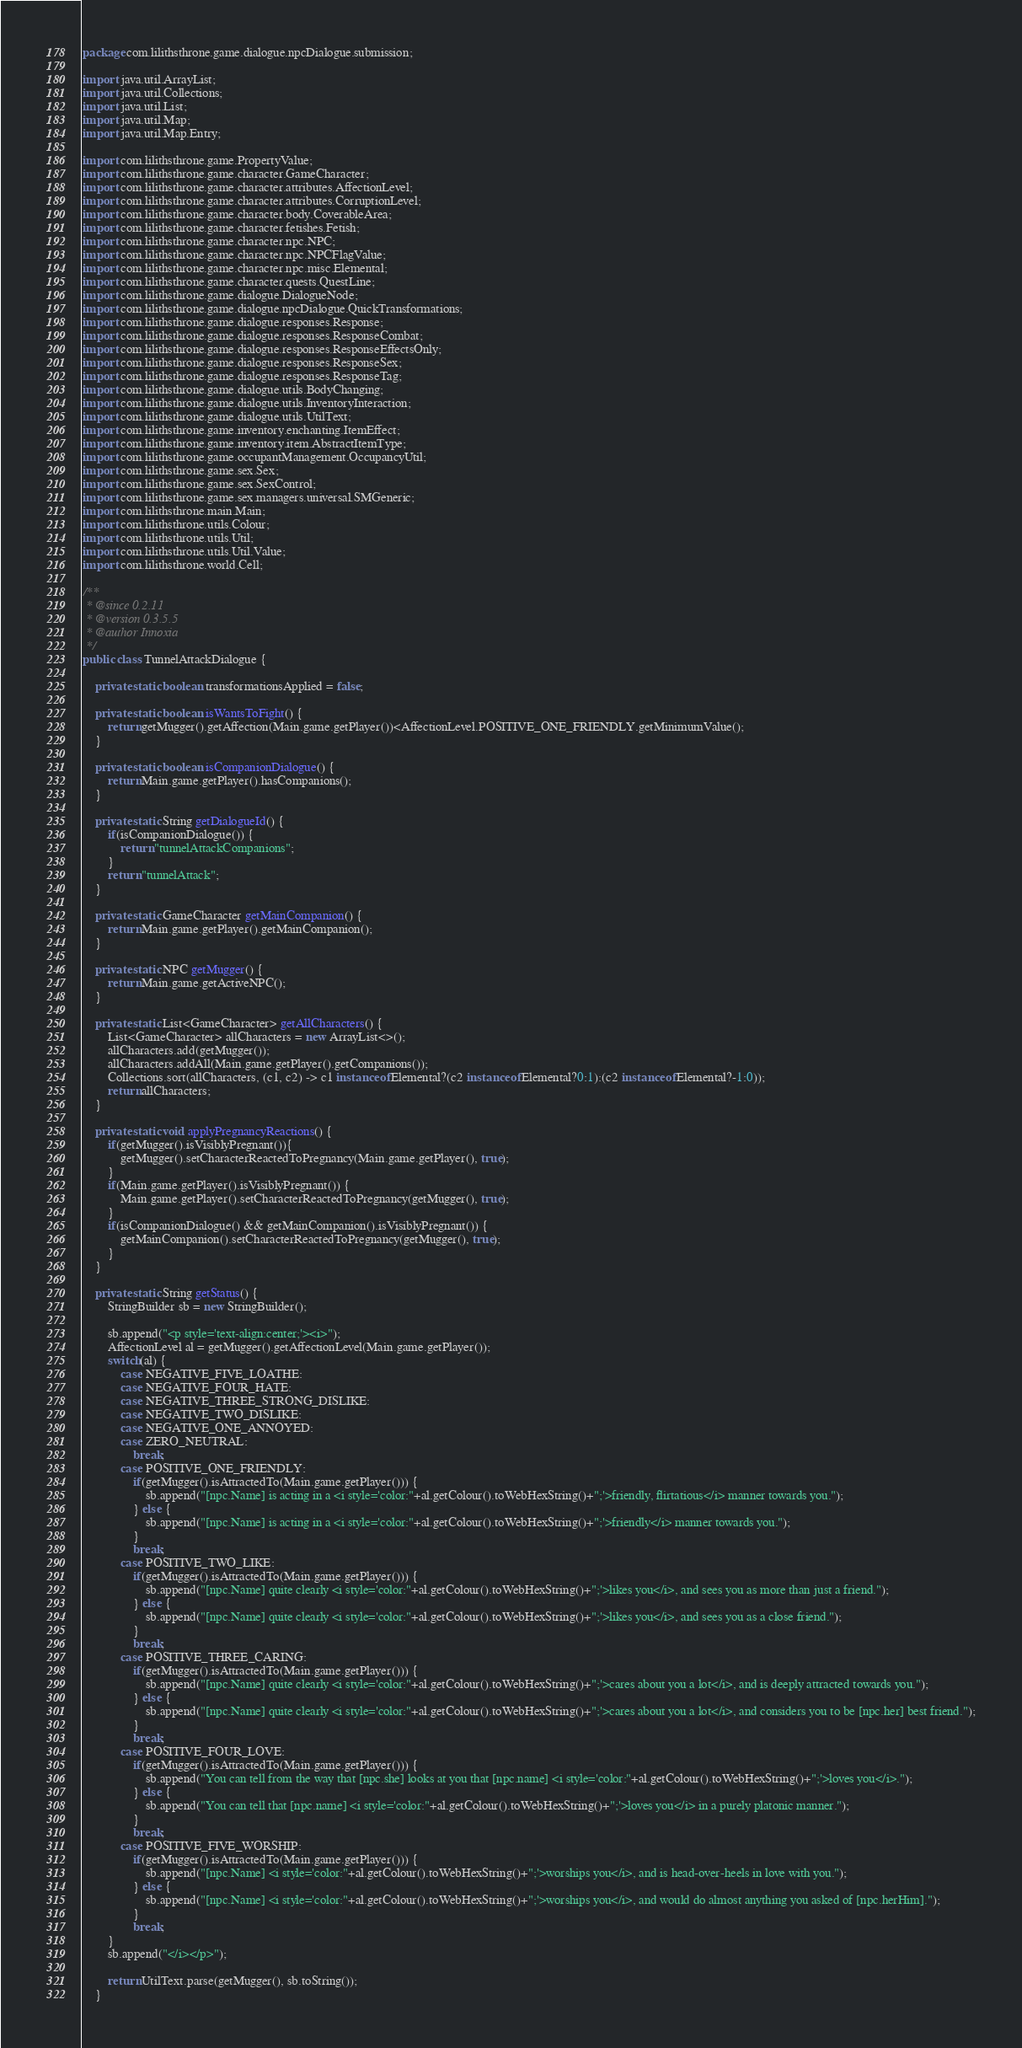Convert code to text. <code><loc_0><loc_0><loc_500><loc_500><_Java_>package com.lilithsthrone.game.dialogue.npcDialogue.submission;

import java.util.ArrayList;
import java.util.Collections;
import java.util.List;
import java.util.Map;
import java.util.Map.Entry;

import com.lilithsthrone.game.PropertyValue;
import com.lilithsthrone.game.character.GameCharacter;
import com.lilithsthrone.game.character.attributes.AffectionLevel;
import com.lilithsthrone.game.character.attributes.CorruptionLevel;
import com.lilithsthrone.game.character.body.CoverableArea;
import com.lilithsthrone.game.character.fetishes.Fetish;
import com.lilithsthrone.game.character.npc.NPC;
import com.lilithsthrone.game.character.npc.NPCFlagValue;
import com.lilithsthrone.game.character.npc.misc.Elemental;
import com.lilithsthrone.game.character.quests.QuestLine;
import com.lilithsthrone.game.dialogue.DialogueNode;
import com.lilithsthrone.game.dialogue.npcDialogue.QuickTransformations;
import com.lilithsthrone.game.dialogue.responses.Response;
import com.lilithsthrone.game.dialogue.responses.ResponseCombat;
import com.lilithsthrone.game.dialogue.responses.ResponseEffectsOnly;
import com.lilithsthrone.game.dialogue.responses.ResponseSex;
import com.lilithsthrone.game.dialogue.responses.ResponseTag;
import com.lilithsthrone.game.dialogue.utils.BodyChanging;
import com.lilithsthrone.game.dialogue.utils.InventoryInteraction;
import com.lilithsthrone.game.dialogue.utils.UtilText;
import com.lilithsthrone.game.inventory.enchanting.ItemEffect;
import com.lilithsthrone.game.inventory.item.AbstractItemType;
import com.lilithsthrone.game.occupantManagement.OccupancyUtil;
import com.lilithsthrone.game.sex.Sex;
import com.lilithsthrone.game.sex.SexControl;
import com.lilithsthrone.game.sex.managers.universal.SMGeneric;
import com.lilithsthrone.main.Main;
import com.lilithsthrone.utils.Colour;
import com.lilithsthrone.utils.Util;
import com.lilithsthrone.utils.Util.Value;
import com.lilithsthrone.world.Cell;

/**
 * @since 0.2.11
 * @version 0.3.5.5
 * @author Innoxia
 */
public class TunnelAttackDialogue {

	private static boolean transformationsApplied = false;
	
	private static boolean isWantsToFight() {
		return getMugger().getAffection(Main.game.getPlayer())<AffectionLevel.POSITIVE_ONE_FRIENDLY.getMinimumValue();
	}

	private static boolean isCompanionDialogue() {
		return Main.game.getPlayer().hasCompanions();
	}
	
	private static String getDialogueId() {
		if(isCompanionDialogue()) {
			return "tunnelAttackCompanions";
		}
		return "tunnelAttack";
	}

	private static GameCharacter getMainCompanion() {
		return Main.game.getPlayer().getMainCompanion();
	}
	
	private static NPC getMugger() {
		return Main.game.getActiveNPC();
	}
	
	private static List<GameCharacter> getAllCharacters() {
		List<GameCharacter> allCharacters = new ArrayList<>();
		allCharacters.add(getMugger());
		allCharacters.addAll(Main.game.getPlayer().getCompanions());
		Collections.sort(allCharacters, (c1, c2) -> c1 instanceof Elemental?(c2 instanceof Elemental?0:1):(c2 instanceof Elemental?-1:0));
		return allCharacters;
	}
	
	private static void applyPregnancyReactions() {
		if(getMugger().isVisiblyPregnant()){
			getMugger().setCharacterReactedToPregnancy(Main.game.getPlayer(), true);
		}
		if(Main.game.getPlayer().isVisiblyPregnant()) {
			Main.game.getPlayer().setCharacterReactedToPregnancy(getMugger(), true);
		}
		if(isCompanionDialogue() && getMainCompanion().isVisiblyPregnant()) {
			getMainCompanion().setCharacterReactedToPregnancy(getMugger(), true);
		}
	}
	
	private static String getStatus() {
		StringBuilder sb = new StringBuilder();
		
		sb.append("<p style='text-align:center;'><i>");
		AffectionLevel al = getMugger().getAffectionLevel(Main.game.getPlayer());
		switch(al) {
			case NEGATIVE_FIVE_LOATHE:
			case NEGATIVE_FOUR_HATE:
			case NEGATIVE_THREE_STRONG_DISLIKE:
			case NEGATIVE_TWO_DISLIKE:
			case NEGATIVE_ONE_ANNOYED:
			case ZERO_NEUTRAL:
				break;
			case POSITIVE_ONE_FRIENDLY:
				if(getMugger().isAttractedTo(Main.game.getPlayer())) {
					sb.append("[npc.Name] is acting in a <i style='color:"+al.getColour().toWebHexString()+";'>friendly, flirtatious</i> manner towards you.");
				} else {
					sb.append("[npc.Name] is acting in a <i style='color:"+al.getColour().toWebHexString()+";'>friendly</i> manner towards you.");
				}
				break;
			case POSITIVE_TWO_LIKE:
				if(getMugger().isAttractedTo(Main.game.getPlayer())) {
					sb.append("[npc.Name] quite clearly <i style='color:"+al.getColour().toWebHexString()+";'>likes you</i>, and sees you as more than just a friend.");
				} else {
					sb.append("[npc.Name] quite clearly <i style='color:"+al.getColour().toWebHexString()+";'>likes you</i>, and sees you as a close friend.");
				}
				break;
			case POSITIVE_THREE_CARING:
				if(getMugger().isAttractedTo(Main.game.getPlayer())) {
					sb.append("[npc.Name] quite clearly <i style='color:"+al.getColour().toWebHexString()+";'>cares about you a lot</i>, and is deeply attracted towards you.");
				} else {
					sb.append("[npc.Name] quite clearly <i style='color:"+al.getColour().toWebHexString()+";'>cares about you a lot</i>, and considers you to be [npc.her] best friend.");
				}
				break;
			case POSITIVE_FOUR_LOVE:
				if(getMugger().isAttractedTo(Main.game.getPlayer())) {
					sb.append("You can tell from the way that [npc.she] looks at you that [npc.name] <i style='color:"+al.getColour().toWebHexString()+";'>loves you</i>.");
				} else {
					sb.append("You can tell that [npc.name] <i style='color:"+al.getColour().toWebHexString()+";'>loves you</i> in a purely platonic manner.");
				}
				break;
			case POSITIVE_FIVE_WORSHIP:
				if(getMugger().isAttractedTo(Main.game.getPlayer())) {
					sb.append("[npc.Name] <i style='color:"+al.getColour().toWebHexString()+";'>worships you</i>, and is head-over-heels in love with you.");
				} else {
					sb.append("[npc.Name] <i style='color:"+al.getColour().toWebHexString()+";'>worships you</i>, and would do almost anything you asked of [npc.herHim].");
				}
				break;
		}
		sb.append("</i></p>");
		
		return UtilText.parse(getMugger(), sb.toString());
	}
</code> 